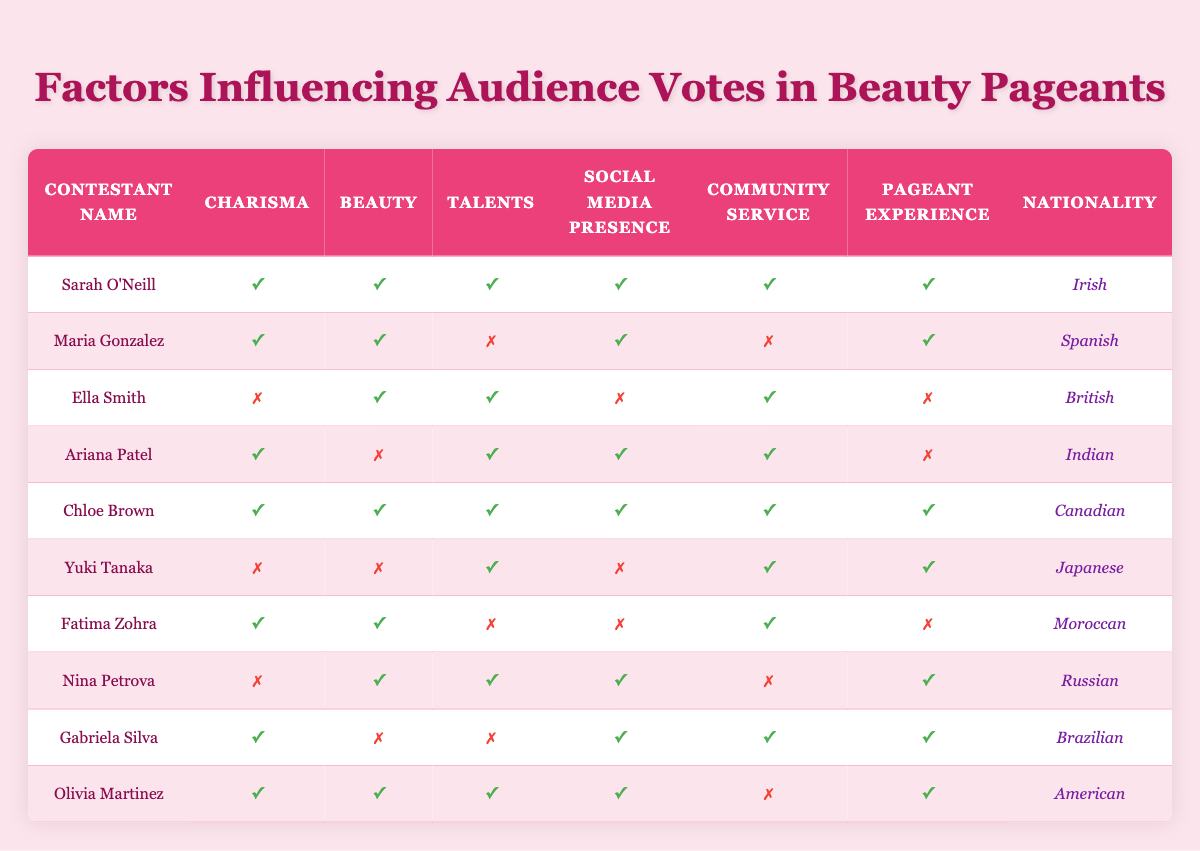What is the nationality of the contestant with the most factors marked as true? Sarah O'Neill has all factors marked as true, and her nationality is Irish.
Answer: Irish How many contestants have both charisma and beauty? The contestants that have both charisma and beauty are Sarah O'Neill, Maria Gonzalez, Chloe Brown, Fatima Zohra, and Olivia Martinez. There are five such contestants.
Answer: 5 Is Ella Smith known for her community service? Ella Smith has the community service factor marked as true.
Answer: Yes Which contestant has the highest number of true factors but is not from Ireland? Chloe Brown has six factors marked as true and is from Canada.
Answer: Chloe Brown How many contestants have pageant experience but do not have charisma? The contestants with pageant experience but without charisma are Ella Smith, Yuki Tanaka, and Nina Petrova; this totals to three contestants.
Answer: 3 If we consider only the contestants who have both beauty and talents, how many are there? The contestants with both beauty and talents are Sarah O'Neill, Maria Gonzalez, Ella Smith, Ariana Patel, Chloe Brown, Nina Petrova, and Olivia Martinez. Totaling these gives us seven contestants.
Answer: 7 Does Gabriela Silva have talents marked as true? Gabriela Silva has the talents factor marked as false.
Answer: No What is the nationality of the contestant who has all factors marked as false? Yuki Tanaka has charisma and beauty marked as false, alongside false social media presence and true community service and pageant experience. Her nationality is Japanese.
Answer: Japanese How many contestants have a social media presence but lack community service? Five contestants—Maria Gonzalez, Ariana Patel, Gabriela Silva, and Olivia Martinez—have a social media presence but lack community service.
Answer: 4 